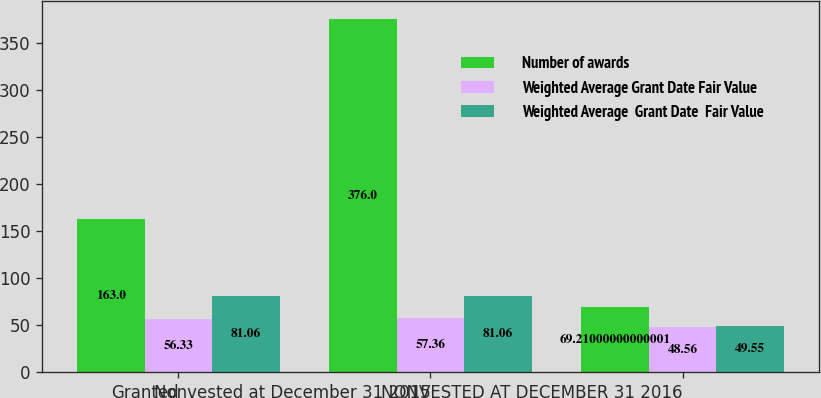Convert chart. <chart><loc_0><loc_0><loc_500><loc_500><stacked_bar_chart><ecel><fcel>Granted<fcel>Nonvested at December 31 2015<fcel>NONVESTED AT DECEMBER 31 2016<nl><fcel>Number of awards<fcel>163<fcel>376<fcel>69.21<nl><fcel>Weighted Average Grant Date Fair Value<fcel>56.33<fcel>57.36<fcel>48.56<nl><fcel>Weighted Average  Grant Date  Fair Value<fcel>81.06<fcel>81.06<fcel>49.55<nl></chart> 